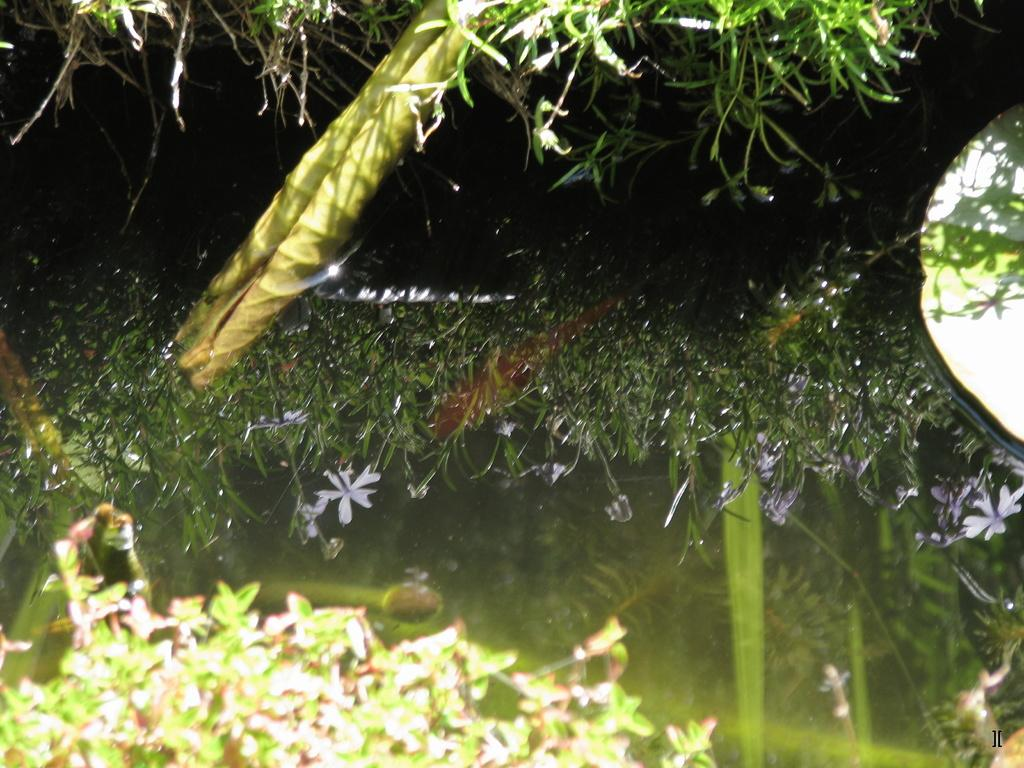What type of plants can be seen in the image? There are plants with flowers in the image. What other natural elements are present in the image? There is grass in the image. What is the unique feature of the image? There is a reflection of the plants and grass on the water. Where is the tin store located in the image? There is no tin store present in the image. What type of record can be heard playing in the background of the image? There is no record playing in the background of the image, as it is a still image. 